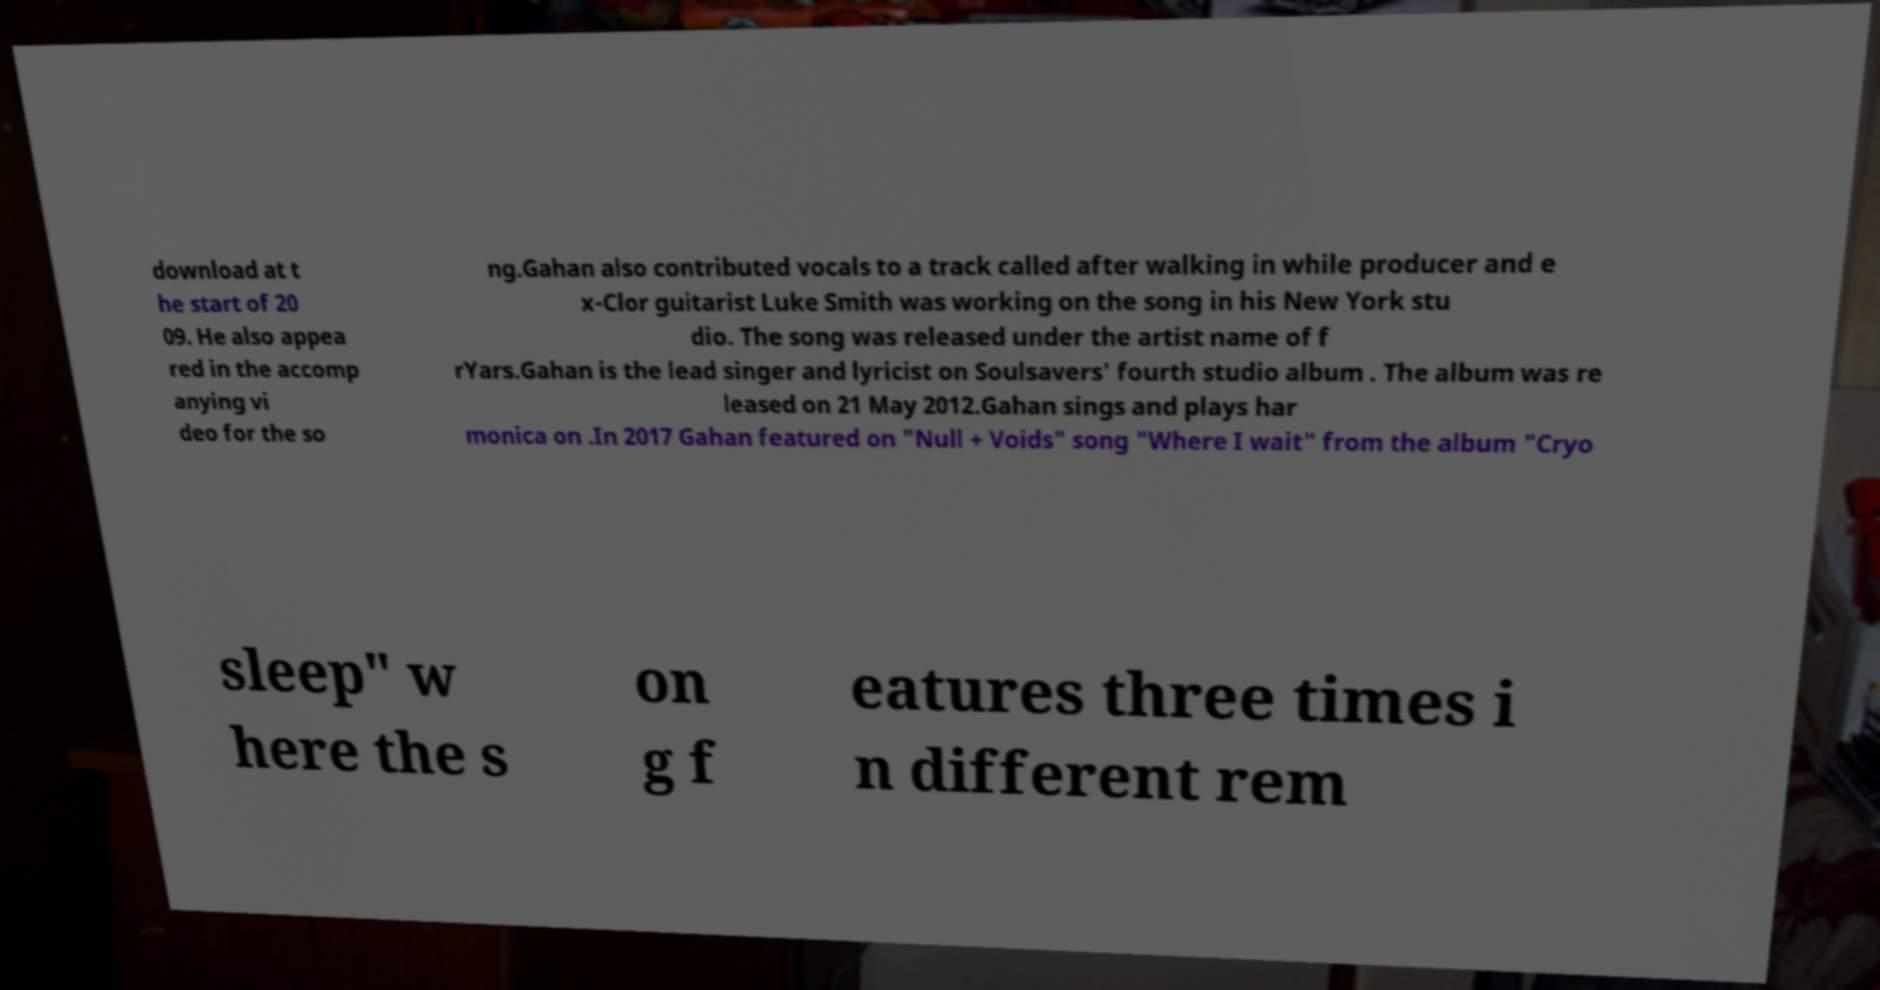What messages or text are displayed in this image? I need them in a readable, typed format. download at t he start of 20 09. He also appea red in the accomp anying vi deo for the so ng.Gahan also contributed vocals to a track called after walking in while producer and e x-Clor guitarist Luke Smith was working on the song in his New York stu dio. The song was released under the artist name of f rYars.Gahan is the lead singer and lyricist on Soulsavers' fourth studio album . The album was re leased on 21 May 2012.Gahan sings and plays har monica on .In 2017 Gahan featured on "Null + Voids" song "Where I wait" from the album "Cryo sleep" w here the s on g f eatures three times i n different rem 